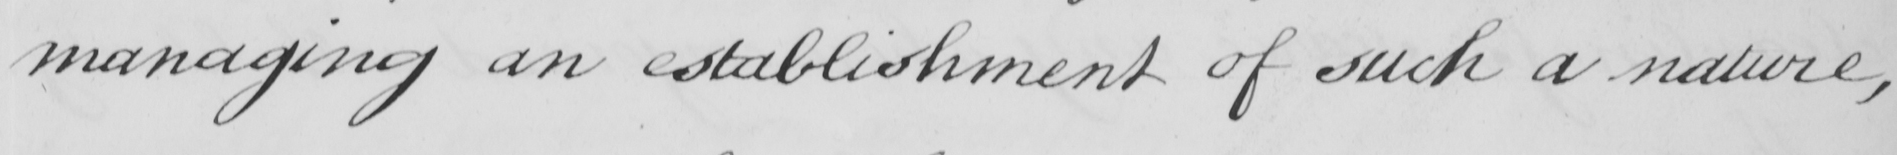Can you read and transcribe this handwriting? managing an establishment of such a nature , 